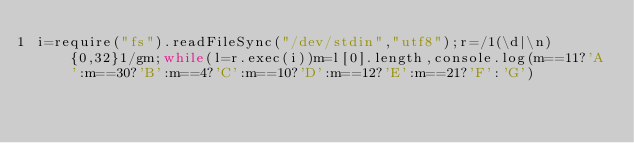Convert code to text. <code><loc_0><loc_0><loc_500><loc_500><_JavaScript_>i=require("fs").readFileSync("/dev/stdin","utf8");r=/1(\d|\n){0,32}1/gm;while(l=r.exec(i))m=l[0].length,console.log(m==11?'A':m==30?'B':m==4?'C':m==10?'D':m==12?'E':m==21?'F':'G')</code> 